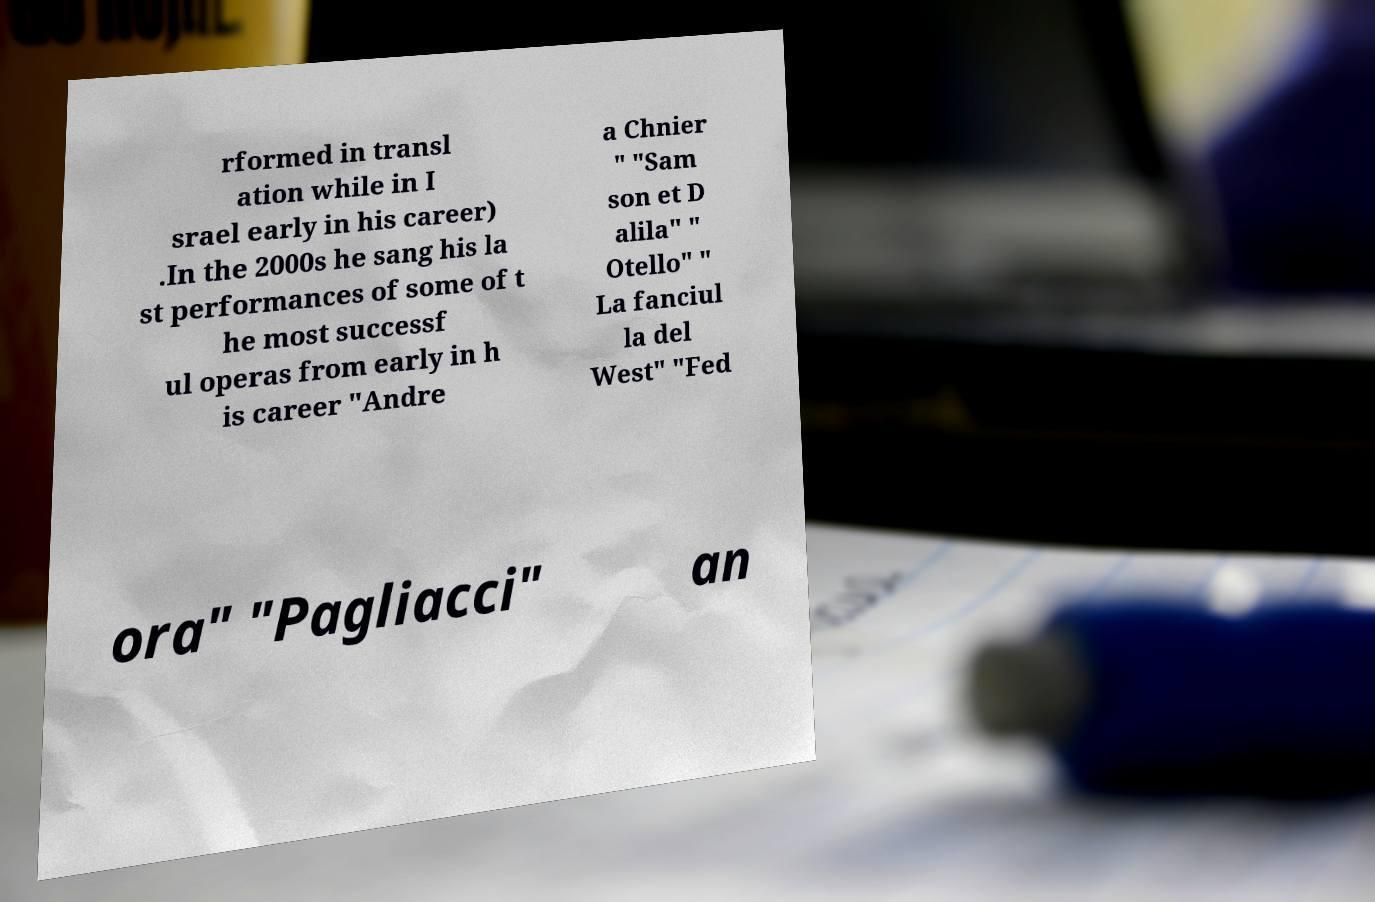Can you read and provide the text displayed in the image?This photo seems to have some interesting text. Can you extract and type it out for me? rformed in transl ation while in I srael early in his career) .In the 2000s he sang his la st performances of some of t he most successf ul operas from early in h is career "Andre a Chnier " "Sam son et D alila" " Otello" " La fanciul la del West" "Fed ora" "Pagliacci" an 